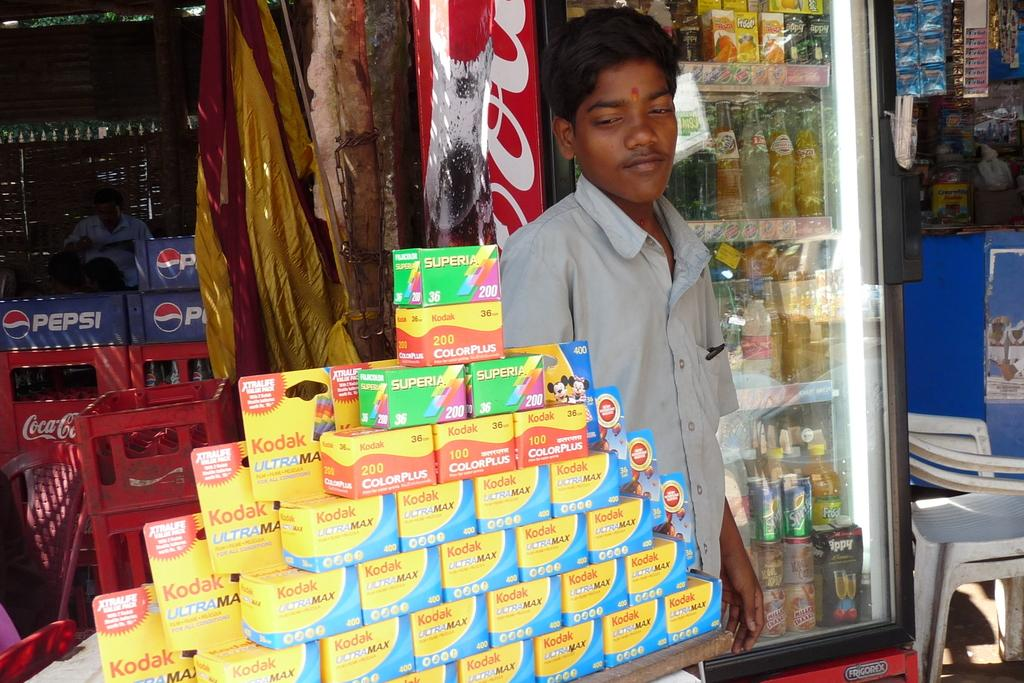<image>
Relay a brief, clear account of the picture shown. A man is standing next to a stack of Kodak film boxes. 